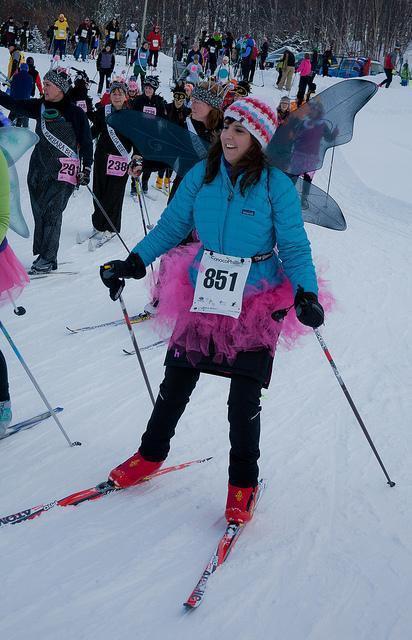What color is the woman's skirt who is number 851 in this ski race?
Choose the correct response, then elucidate: 'Answer: answer
Rationale: rationale.'
Options: Blue, orange, red, pink. Answer: pink.
Rationale: The color is pink. 